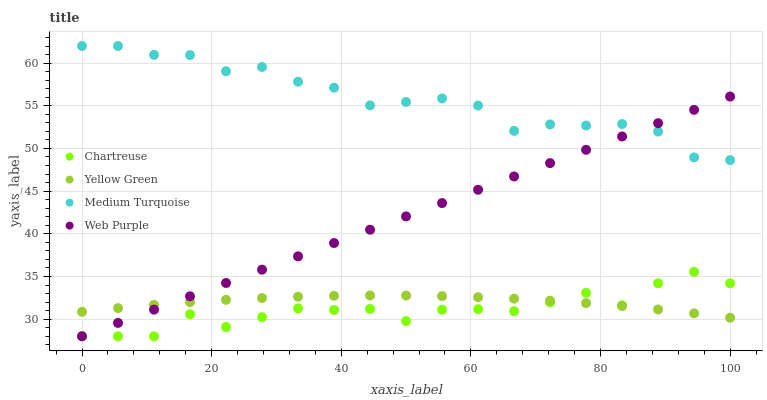Does Chartreuse have the minimum area under the curve?
Answer yes or no. Yes. Does Medium Turquoise have the maximum area under the curve?
Answer yes or no. Yes. Does Yellow Green have the minimum area under the curve?
Answer yes or no. No. Does Yellow Green have the maximum area under the curve?
Answer yes or no. No. Is Web Purple the smoothest?
Answer yes or no. Yes. Is Chartreuse the roughest?
Answer yes or no. Yes. Is Yellow Green the smoothest?
Answer yes or no. No. Is Yellow Green the roughest?
Answer yes or no. No. Does Web Purple have the lowest value?
Answer yes or no. Yes. Does Yellow Green have the lowest value?
Answer yes or no. No. Does Medium Turquoise have the highest value?
Answer yes or no. Yes. Does Chartreuse have the highest value?
Answer yes or no. No. Is Yellow Green less than Medium Turquoise?
Answer yes or no. Yes. Is Medium Turquoise greater than Chartreuse?
Answer yes or no. Yes. Does Chartreuse intersect Web Purple?
Answer yes or no. Yes. Is Chartreuse less than Web Purple?
Answer yes or no. No. Is Chartreuse greater than Web Purple?
Answer yes or no. No. Does Yellow Green intersect Medium Turquoise?
Answer yes or no. No. 